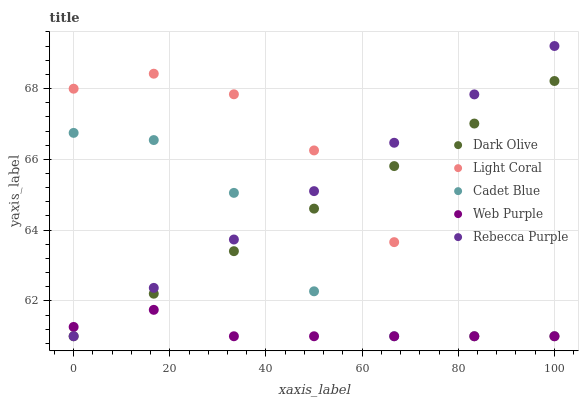Does Web Purple have the minimum area under the curve?
Answer yes or no. Yes. Does Light Coral have the maximum area under the curve?
Answer yes or no. Yes. Does Dark Olive have the minimum area under the curve?
Answer yes or no. No. Does Dark Olive have the maximum area under the curve?
Answer yes or no. No. Is Dark Olive the smoothest?
Answer yes or no. Yes. Is Light Coral the roughest?
Answer yes or no. Yes. Is Web Purple the smoothest?
Answer yes or no. No. Is Web Purple the roughest?
Answer yes or no. No. Does Light Coral have the lowest value?
Answer yes or no. Yes. Does Rebecca Purple have the highest value?
Answer yes or no. Yes. Does Dark Olive have the highest value?
Answer yes or no. No. Does Light Coral intersect Dark Olive?
Answer yes or no. Yes. Is Light Coral less than Dark Olive?
Answer yes or no. No. Is Light Coral greater than Dark Olive?
Answer yes or no. No. 